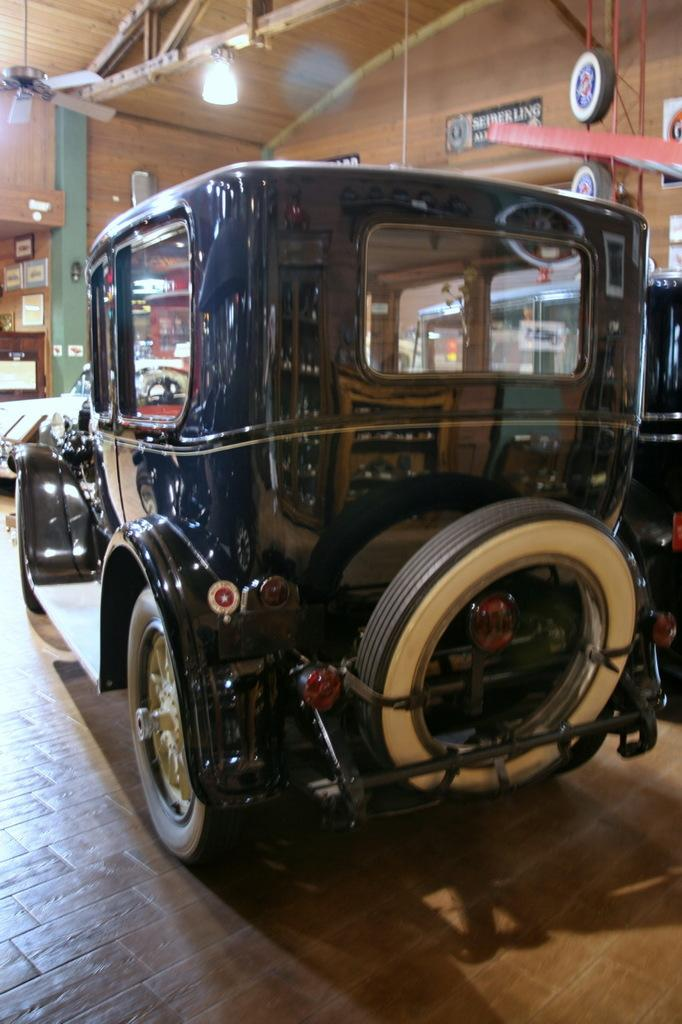What object is on the floor in the image? There is a vehicle visible on the floor. What is located at the top of the image? There is a wall at the top of the image. Can you describe the lighting in the image? There is a light visible in the image. What is on the left side of the image? There is a rack on the left side of the image. Where is the grandmother sitting with her quill in the image? There is no grandmother or quill present in the image. What type of desk can be seen in the image? There is no desk present in the image. 